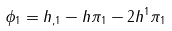Convert formula to latex. <formula><loc_0><loc_0><loc_500><loc_500>\phi _ { 1 } = h _ { , 1 } - h \pi _ { 1 } - 2 h ^ { 1 } \pi _ { 1 }</formula> 